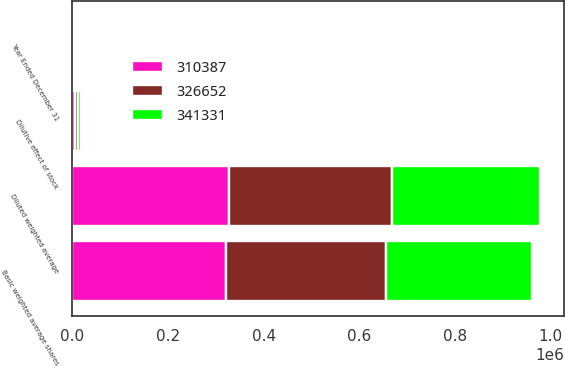<chart> <loc_0><loc_0><loc_500><loc_500><stacked_bar_chart><ecel><fcel>Year Ended December 31<fcel>Basic weighted average shares<fcel>Dilutive effect of stock<fcel>Diluted weighted average<nl><fcel>341331<fcel>2016<fcel>304707<fcel>5680<fcel>310387<nl><fcel>310387<fcel>2015<fcel>321313<fcel>5339<fcel>326652<nl><fcel>326652<fcel>2014<fcel>335192<fcel>6139<fcel>341331<nl></chart> 